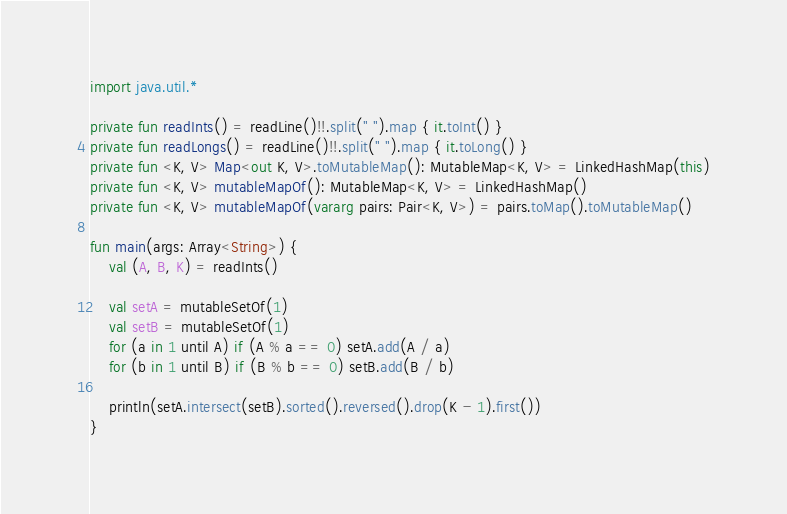Convert code to text. <code><loc_0><loc_0><loc_500><loc_500><_Kotlin_>import java.util.*

private fun readInts() = readLine()!!.split(" ").map { it.toInt() }
private fun readLongs() = readLine()!!.split(" ").map { it.toLong() }
private fun <K, V> Map<out K, V>.toMutableMap(): MutableMap<K, V> = LinkedHashMap(this)
private fun <K, V> mutableMapOf(): MutableMap<K, V> = LinkedHashMap()
private fun <K, V> mutableMapOf(vararg pairs: Pair<K, V>) = pairs.toMap().toMutableMap()

fun main(args: Array<String>) {
    val (A, B, K) = readInts()

    val setA = mutableSetOf(1)
    val setB = mutableSetOf(1)
    for (a in 1 until A) if (A % a == 0) setA.add(A / a)
    for (b in 1 until B) if (B % b == 0) setB.add(B / b)

    println(setA.intersect(setB).sorted().reversed().drop(K - 1).first())
}</code> 